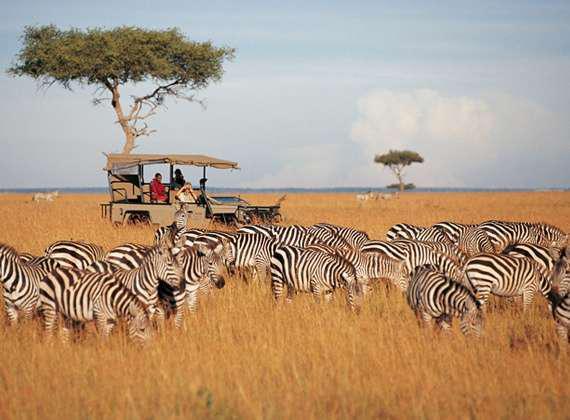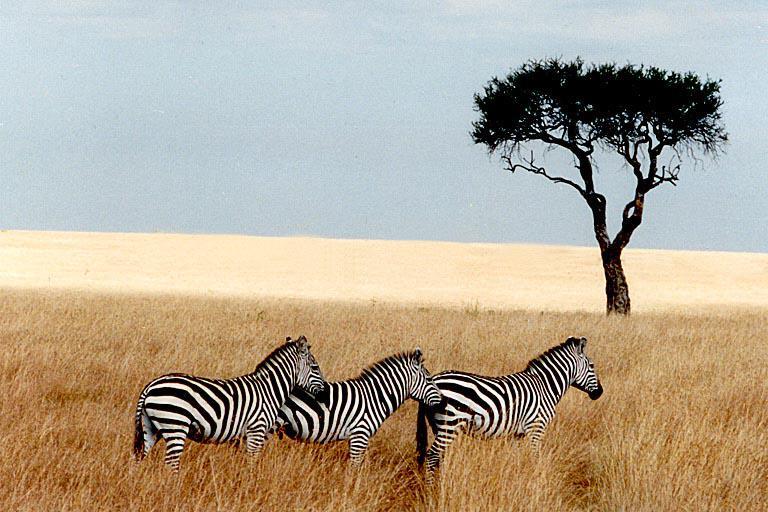The first image is the image on the left, the second image is the image on the right. Assess this claim about the two images: "Each image contains exactly three zebras, and no zebras are standing with their rears facing the camera.". Correct or not? Answer yes or no. No. The first image is the image on the left, the second image is the image on the right. For the images displayed, is the sentence "In the right image, three zebras are heading right." factually correct? Answer yes or no. Yes. 